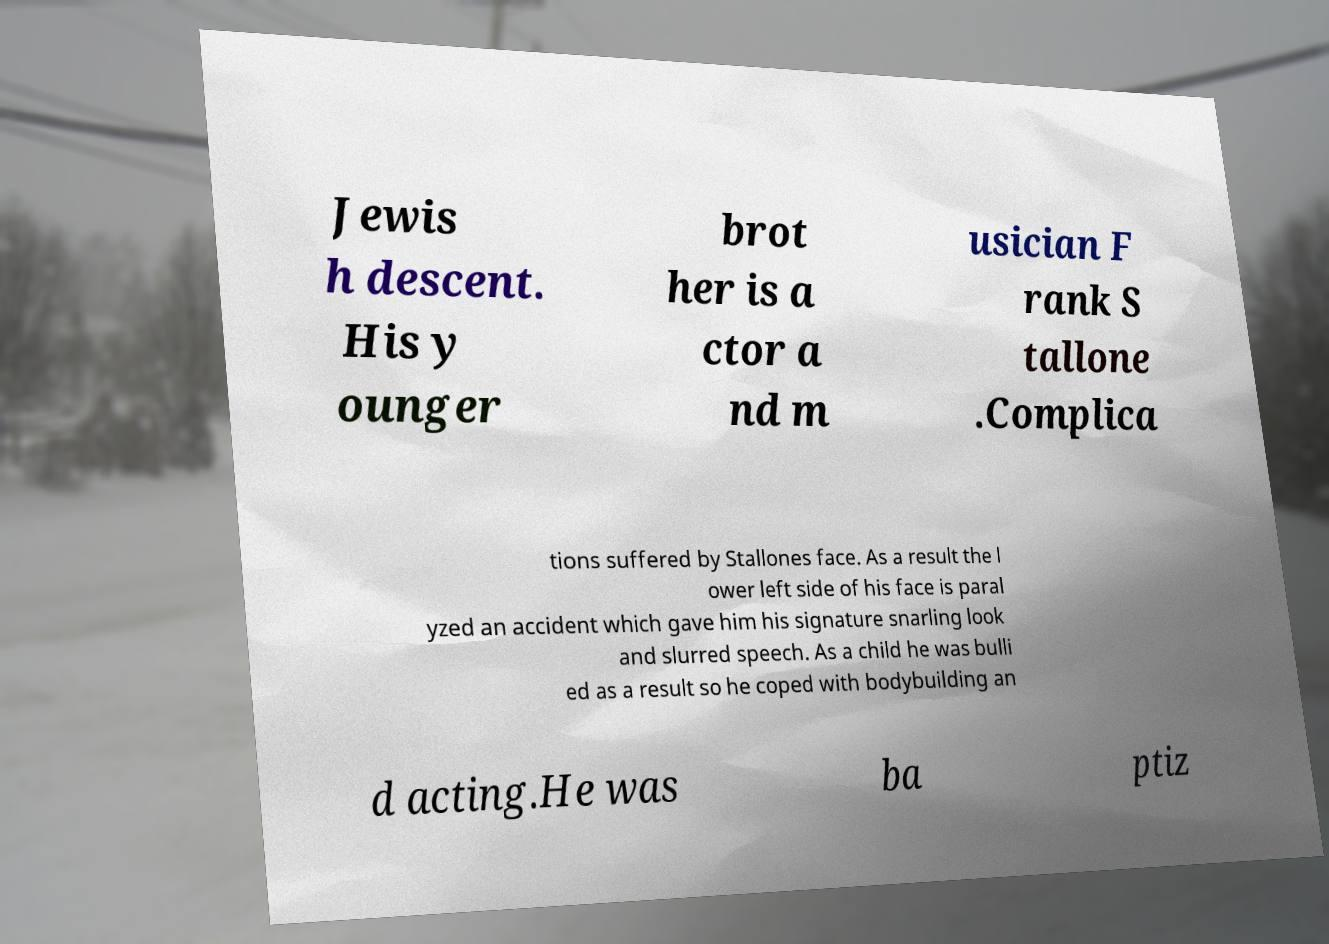There's text embedded in this image that I need extracted. Can you transcribe it verbatim? Jewis h descent. His y ounger brot her is a ctor a nd m usician F rank S tallone .Complica tions suffered by Stallones face. As a result the l ower left side of his face is paral yzed an accident which gave him his signature snarling look and slurred speech. As a child he was bulli ed as a result so he coped with bodybuilding an d acting.He was ba ptiz 